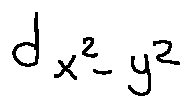<formula> <loc_0><loc_0><loc_500><loc_500>d _ { x ^ { 2 } - y ^ { 2 } }</formula> 